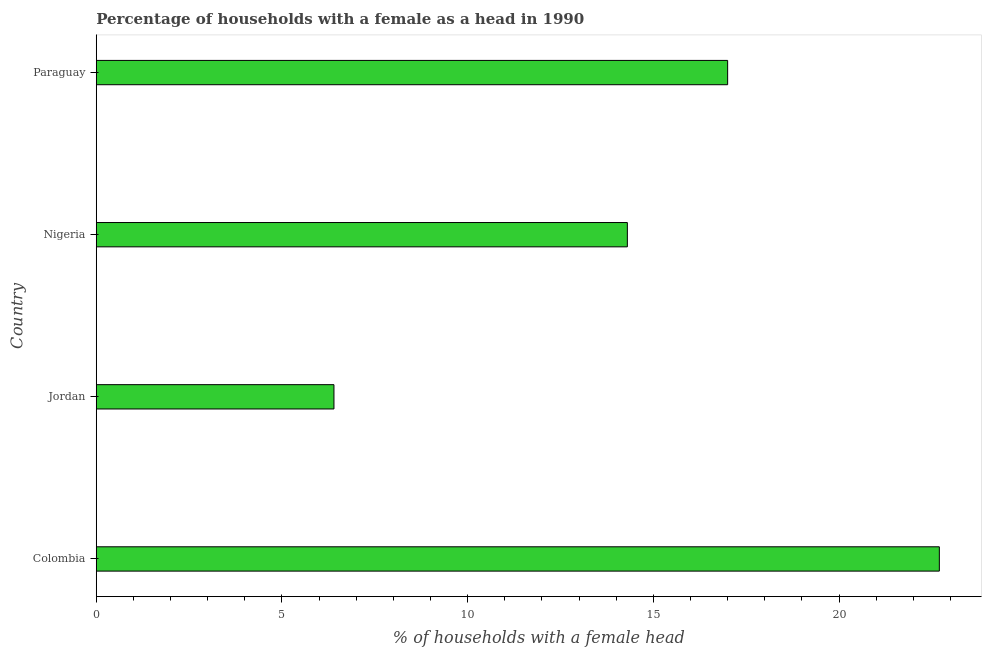Does the graph contain any zero values?
Your response must be concise. No. Does the graph contain grids?
Offer a terse response. No. What is the title of the graph?
Keep it short and to the point. Percentage of households with a female as a head in 1990. What is the label or title of the X-axis?
Ensure brevity in your answer.  % of households with a female head. Across all countries, what is the maximum number of female supervised households?
Provide a succinct answer. 22.7. In which country was the number of female supervised households minimum?
Give a very brief answer. Jordan. What is the sum of the number of female supervised households?
Your answer should be very brief. 60.4. What is the difference between the number of female supervised households in Jordan and Paraguay?
Offer a terse response. -10.6. What is the average number of female supervised households per country?
Ensure brevity in your answer.  15.1. What is the median number of female supervised households?
Ensure brevity in your answer.  15.65. What is the ratio of the number of female supervised households in Colombia to that in Paraguay?
Keep it short and to the point. 1.33. Is the difference between the number of female supervised households in Jordan and Nigeria greater than the difference between any two countries?
Provide a short and direct response. No. What is the difference between the highest and the lowest number of female supervised households?
Give a very brief answer. 16.3. In how many countries, is the number of female supervised households greater than the average number of female supervised households taken over all countries?
Keep it short and to the point. 2. How many bars are there?
Offer a very short reply. 4. How many countries are there in the graph?
Your response must be concise. 4. What is the difference between two consecutive major ticks on the X-axis?
Provide a succinct answer. 5. Are the values on the major ticks of X-axis written in scientific E-notation?
Your answer should be very brief. No. What is the % of households with a female head of Colombia?
Make the answer very short. 22.7. What is the % of households with a female head in Paraguay?
Your response must be concise. 17. What is the difference between the % of households with a female head in Colombia and Jordan?
Offer a terse response. 16.3. What is the difference between the % of households with a female head in Colombia and Nigeria?
Your response must be concise. 8.4. What is the difference between the % of households with a female head in Jordan and Paraguay?
Offer a terse response. -10.6. What is the difference between the % of households with a female head in Nigeria and Paraguay?
Make the answer very short. -2.7. What is the ratio of the % of households with a female head in Colombia to that in Jordan?
Provide a succinct answer. 3.55. What is the ratio of the % of households with a female head in Colombia to that in Nigeria?
Offer a very short reply. 1.59. What is the ratio of the % of households with a female head in Colombia to that in Paraguay?
Your response must be concise. 1.33. What is the ratio of the % of households with a female head in Jordan to that in Nigeria?
Your response must be concise. 0.45. What is the ratio of the % of households with a female head in Jordan to that in Paraguay?
Your answer should be very brief. 0.38. What is the ratio of the % of households with a female head in Nigeria to that in Paraguay?
Your answer should be compact. 0.84. 